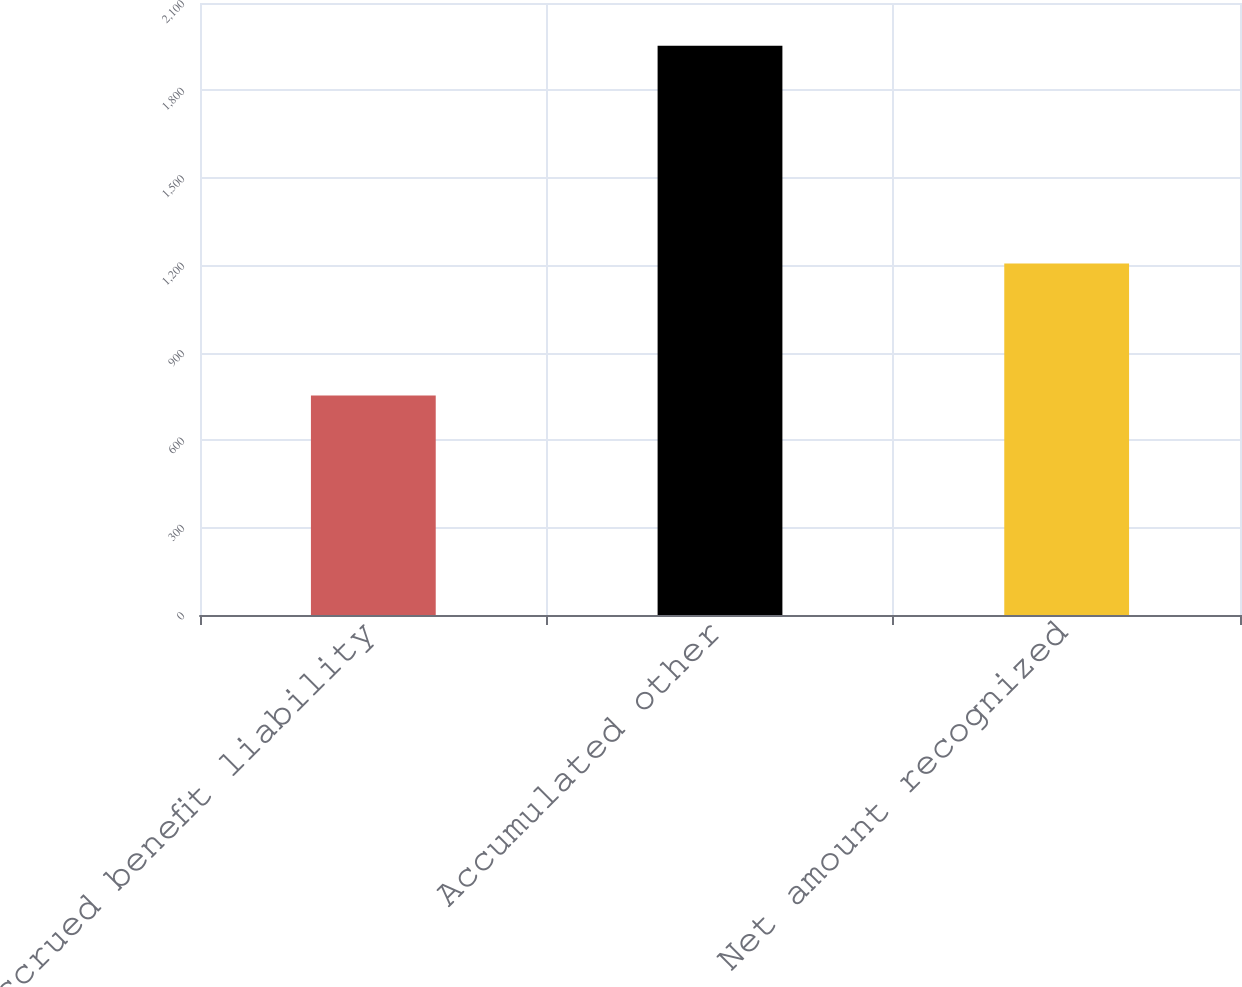Convert chart to OTSL. <chart><loc_0><loc_0><loc_500><loc_500><bar_chart><fcel>Accrued benefit liability<fcel>Accumulated other<fcel>Net amount recognized<nl><fcel>753<fcel>1953<fcel>1206<nl></chart> 